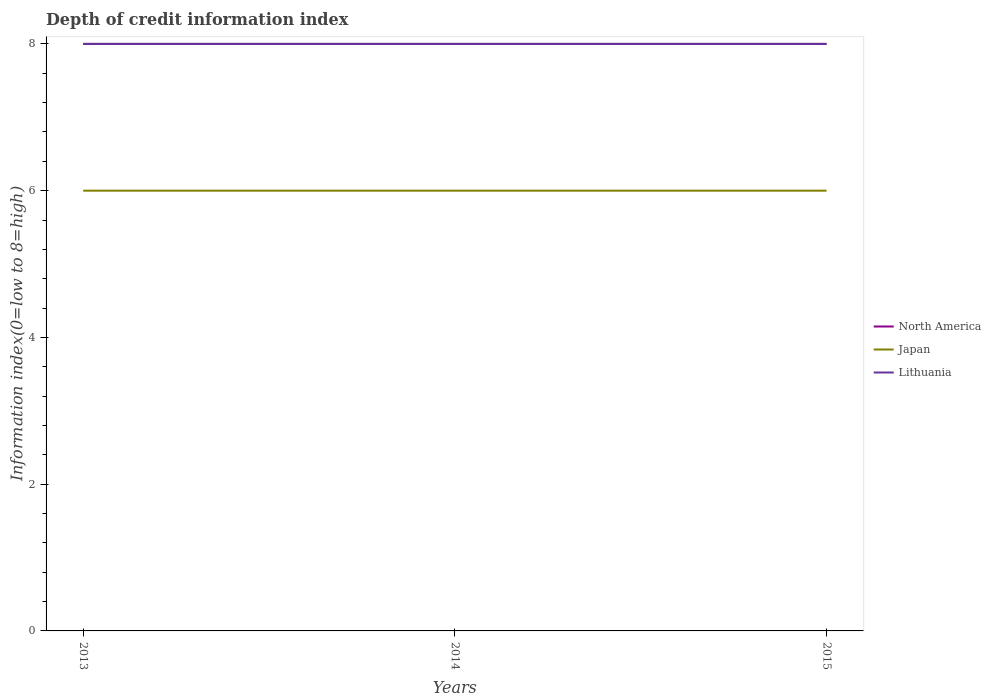Does the line corresponding to North America intersect with the line corresponding to Lithuania?
Make the answer very short. Yes. Is the number of lines equal to the number of legend labels?
Offer a very short reply. Yes. Across all years, what is the maximum information index in Lithuania?
Ensure brevity in your answer.  8. What is the difference between the highest and the second highest information index in North America?
Provide a succinct answer. 0. What is the difference between the highest and the lowest information index in Japan?
Your response must be concise. 0. Is the information index in Japan strictly greater than the information index in North America over the years?
Your response must be concise. Yes. Are the values on the major ticks of Y-axis written in scientific E-notation?
Make the answer very short. No. Does the graph contain grids?
Offer a terse response. No. Where does the legend appear in the graph?
Offer a terse response. Center right. How many legend labels are there?
Offer a terse response. 3. What is the title of the graph?
Provide a short and direct response. Depth of credit information index. Does "Ireland" appear as one of the legend labels in the graph?
Ensure brevity in your answer.  No. What is the label or title of the Y-axis?
Provide a short and direct response. Information index(0=low to 8=high). What is the Information index(0=low to 8=high) of Japan in 2013?
Your answer should be very brief. 6. What is the Information index(0=low to 8=high) of Japan in 2014?
Give a very brief answer. 6. What is the Information index(0=low to 8=high) in Lithuania in 2014?
Ensure brevity in your answer.  8. What is the Information index(0=low to 8=high) in Lithuania in 2015?
Provide a succinct answer. 8. Across all years, what is the maximum Information index(0=low to 8=high) of Lithuania?
Offer a terse response. 8. Across all years, what is the minimum Information index(0=low to 8=high) in Japan?
Keep it short and to the point. 6. Across all years, what is the minimum Information index(0=low to 8=high) of Lithuania?
Your answer should be compact. 8. What is the difference between the Information index(0=low to 8=high) in North America in 2013 and that in 2014?
Give a very brief answer. 0. What is the difference between the Information index(0=low to 8=high) of Lithuania in 2013 and that in 2014?
Ensure brevity in your answer.  0. What is the difference between the Information index(0=low to 8=high) in North America in 2013 and that in 2015?
Keep it short and to the point. 0. What is the difference between the Information index(0=low to 8=high) in Japan in 2013 and that in 2015?
Offer a very short reply. 0. What is the difference between the Information index(0=low to 8=high) in Lithuania in 2013 and that in 2015?
Provide a short and direct response. 0. What is the difference between the Information index(0=low to 8=high) in North America in 2014 and that in 2015?
Your response must be concise. 0. What is the difference between the Information index(0=low to 8=high) in Japan in 2014 and that in 2015?
Provide a short and direct response. 0. What is the difference between the Information index(0=low to 8=high) in Lithuania in 2014 and that in 2015?
Your answer should be compact. 0. What is the difference between the Information index(0=low to 8=high) in Japan in 2013 and the Information index(0=low to 8=high) in Lithuania in 2014?
Provide a succinct answer. -2. What is the difference between the Information index(0=low to 8=high) of North America in 2013 and the Information index(0=low to 8=high) of Japan in 2015?
Your answer should be very brief. 2. What is the difference between the Information index(0=low to 8=high) of Japan in 2013 and the Information index(0=low to 8=high) of Lithuania in 2015?
Your response must be concise. -2. What is the difference between the Information index(0=low to 8=high) of North America in 2014 and the Information index(0=low to 8=high) of Japan in 2015?
Your response must be concise. 2. What is the difference between the Information index(0=low to 8=high) in Japan in 2014 and the Information index(0=low to 8=high) in Lithuania in 2015?
Offer a very short reply. -2. What is the average Information index(0=low to 8=high) in North America per year?
Give a very brief answer. 8. What is the average Information index(0=low to 8=high) of Japan per year?
Your answer should be compact. 6. What is the average Information index(0=low to 8=high) in Lithuania per year?
Make the answer very short. 8. In the year 2013, what is the difference between the Information index(0=low to 8=high) in North America and Information index(0=low to 8=high) in Lithuania?
Your answer should be compact. 0. In the year 2013, what is the difference between the Information index(0=low to 8=high) of Japan and Information index(0=low to 8=high) of Lithuania?
Offer a terse response. -2. In the year 2015, what is the difference between the Information index(0=low to 8=high) of North America and Information index(0=low to 8=high) of Japan?
Ensure brevity in your answer.  2. What is the ratio of the Information index(0=low to 8=high) in Japan in 2013 to that in 2014?
Your answer should be very brief. 1. What is the ratio of the Information index(0=low to 8=high) of Lithuania in 2013 to that in 2014?
Your answer should be compact. 1. What is the ratio of the Information index(0=low to 8=high) in Lithuania in 2013 to that in 2015?
Offer a terse response. 1. What is the ratio of the Information index(0=low to 8=high) of North America in 2014 to that in 2015?
Your response must be concise. 1. What is the difference between the highest and the second highest Information index(0=low to 8=high) in North America?
Provide a succinct answer. 0. What is the difference between the highest and the second highest Information index(0=low to 8=high) of Japan?
Your answer should be very brief. 0. What is the difference between the highest and the second highest Information index(0=low to 8=high) of Lithuania?
Your answer should be compact. 0. What is the difference between the highest and the lowest Information index(0=low to 8=high) in Lithuania?
Ensure brevity in your answer.  0. 